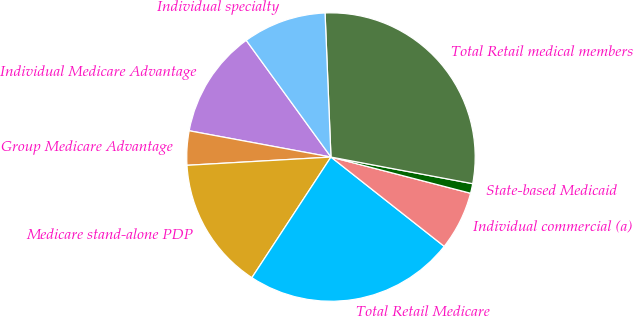Convert chart. <chart><loc_0><loc_0><loc_500><loc_500><pie_chart><fcel>Individual Medicare Advantage<fcel>Group Medicare Advantage<fcel>Medicare stand-alone PDP<fcel>Total Retail Medicare<fcel>Individual commercial (a)<fcel>State-based Medicaid<fcel>Total Retail medical members<fcel>Individual specialty<nl><fcel>12.09%<fcel>3.83%<fcel>14.85%<fcel>23.61%<fcel>6.59%<fcel>1.08%<fcel>28.61%<fcel>9.34%<nl></chart> 